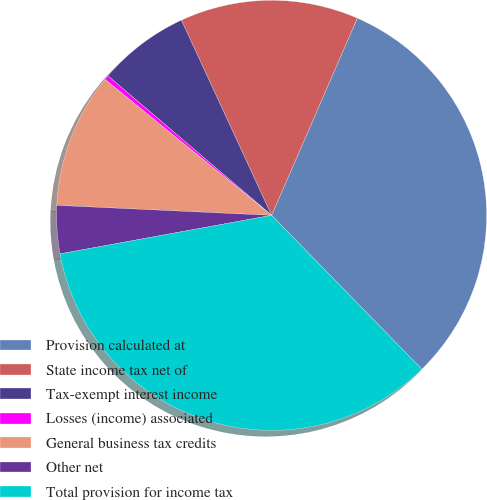Convert chart to OTSL. <chart><loc_0><loc_0><loc_500><loc_500><pie_chart><fcel>Provision calculated at<fcel>State income tax net of<fcel>Tax-exempt interest income<fcel>Losses (income) associated<fcel>General business tax credits<fcel>Other net<fcel>Total provision for income tax<nl><fcel>31.17%<fcel>13.42%<fcel>6.88%<fcel>0.34%<fcel>10.15%<fcel>3.61%<fcel>34.44%<nl></chart> 